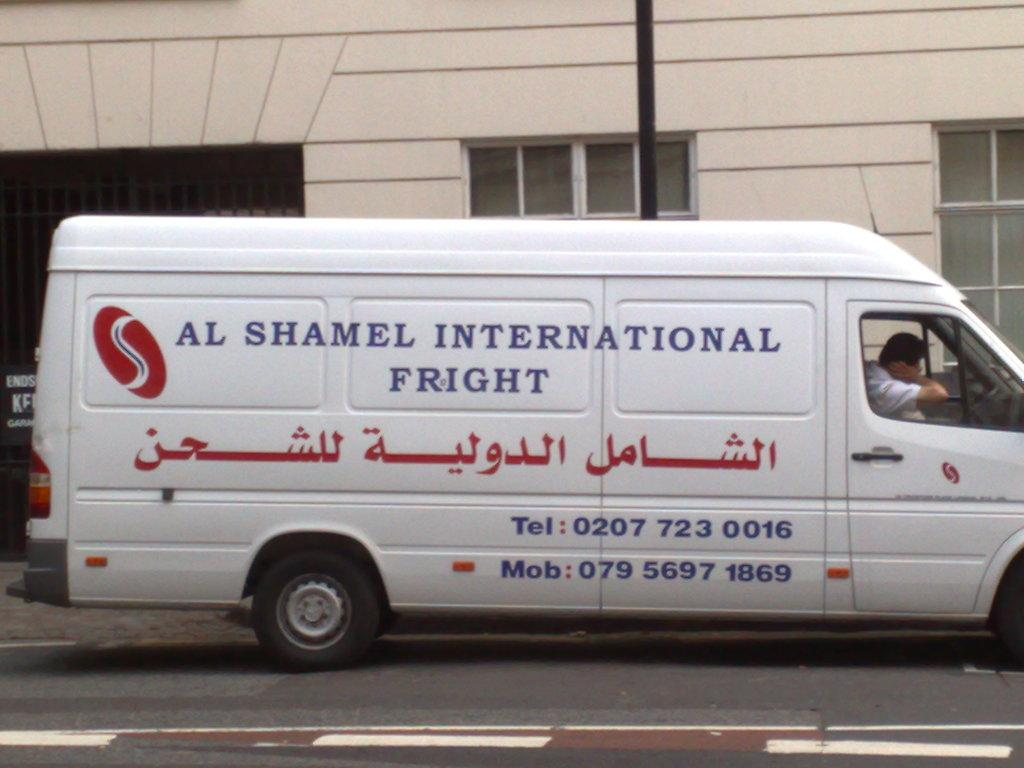<image>
Relay a brief, clear account of the picture shown. A white van with arabic text on the bottom and sal shamel international fright on the top. 